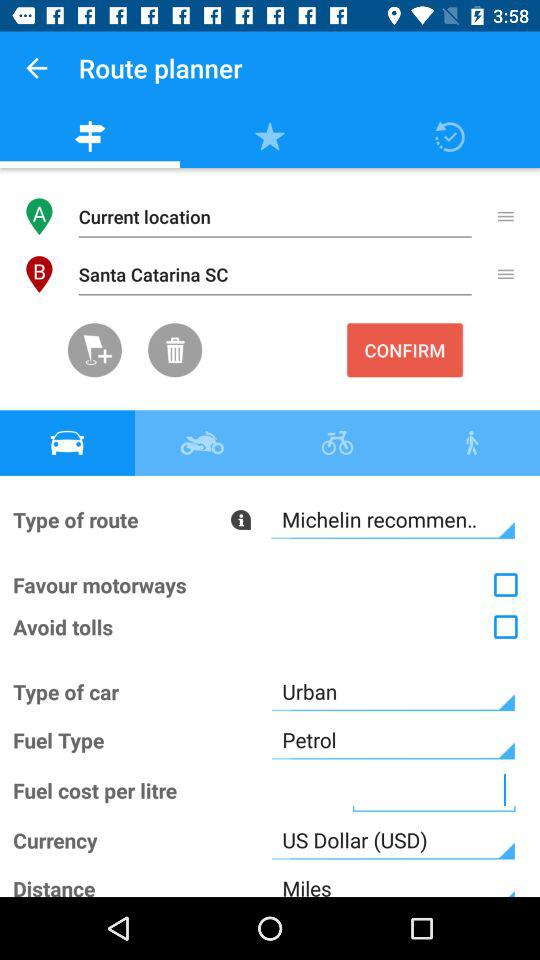What is the current status of the "Favour motorways"? The current status of the "Favour motorways" is "off". 